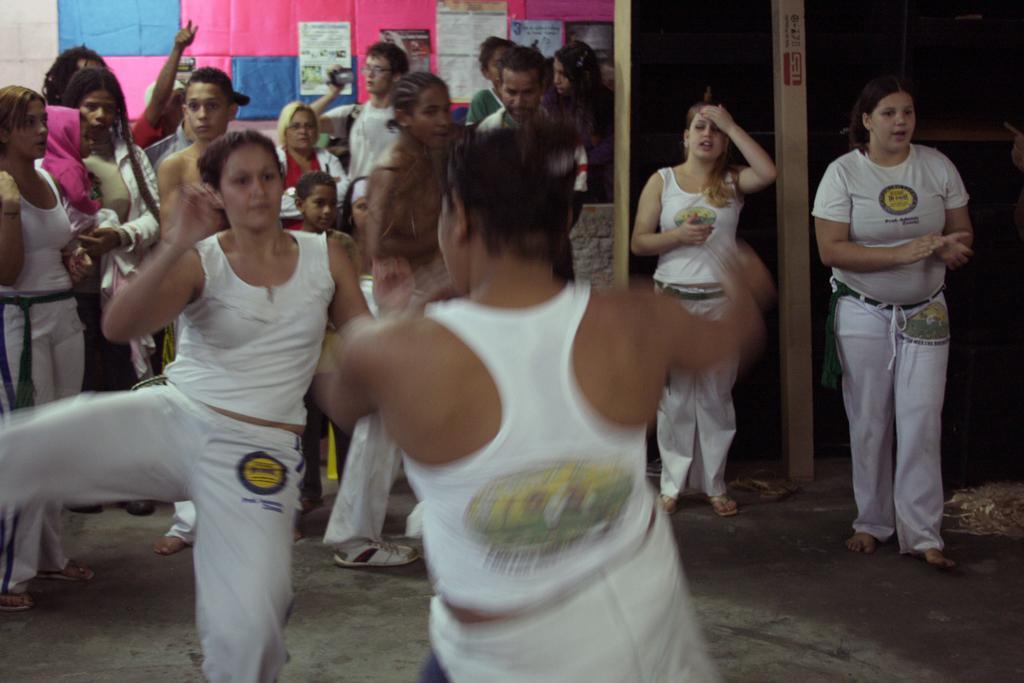Describe this image in one or two sentences. As we can see in the image there are group of people. These two people are dancing and in the background there are posters and a white color wall. 